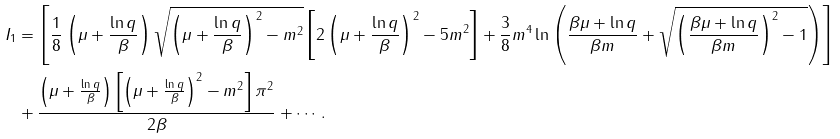<formula> <loc_0><loc_0><loc_500><loc_500>I _ { 1 } & = \left [ \frac { 1 } { 8 } \left ( \mu + \frac { \ln q } { \beta } \right ) \sqrt { \left ( \mu + \frac { \ln q } { \beta } \right ) ^ { 2 } - m ^ { 2 } } \left [ 2 \left ( \mu + \frac { \ln q } { \beta } \right ) ^ { 2 } - 5 m ^ { 2 } \right ] + \frac { 3 } { 8 } m ^ { 4 } \ln \left ( \frac { \beta \mu + \ln q } { \beta m } + \sqrt { \left ( \frac { \beta \mu + \ln q } { \beta m } \right ) ^ { 2 } - 1 } \right ) \right ] \\ & + \frac { \left ( \mu + \frac { \ln q } { \beta } \right ) \left [ \left ( \mu + \frac { \ln q } { \beta } \right ) ^ { 2 } - m ^ { 2 } \right ] \pi ^ { 2 } } { 2 \beta } + \cdots .</formula> 